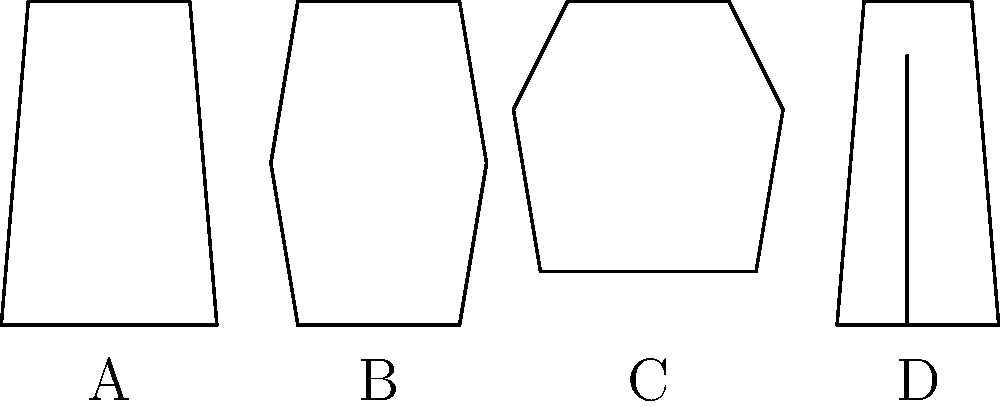Which clothing silhouette represents the most appropriate professional attire for a job interview in a corporate setting? Let's analyze each option:

1. Option A: This silhouette represents a suit, which is considered the most formal and professional attire. It typically consists of a matching jacket and trousers or skirt, often worn with a dress shirt or blouse.

2. Option B: This silhouette appears to be a dress. While dresses can be appropriate for professional settings, they may not always be the safest choice for a job interview, especially in more conservative industries.

3. Option C: This silhouette represents a t-shirt, which is generally too casual for a corporate job interview.

4. Option D: This silhouette appears to be jeans, which are also typically too casual for a corporate job interview.

For a job interview in a corporate setting, it's best to err on the side of caution and choose the most formal option. A suit (Option A) is universally accepted as appropriate interview attire across most industries and positions. It conveys professionalism, attention to detail, and respect for the interview process.

While dress codes can vary depending on the company culture, for a first impression at a job interview, a suit is almost always the safest and most professional choice.
Answer: A 